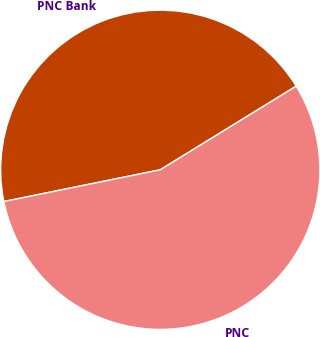<chart> <loc_0><loc_0><loc_500><loc_500><pie_chart><fcel>PNC Bank<fcel>PNC<nl><fcel>44.41%<fcel>55.59%<nl></chart> 